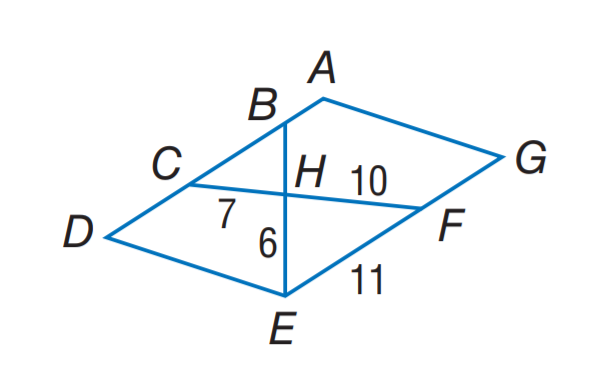Answer the mathemtical geometry problem and directly provide the correct option letter.
Question: Find the perimeter of the \triangle C B H, if \triangle C B H \sim \triangle F E H, A D E G is a parallelogram, C H = 7, F H = 10, F E = 11, and E H = 6. Rounded to the nearest tenth.
Choices: A: 10.6 B: 17.6 C: 18.9 D: 20.3 C 